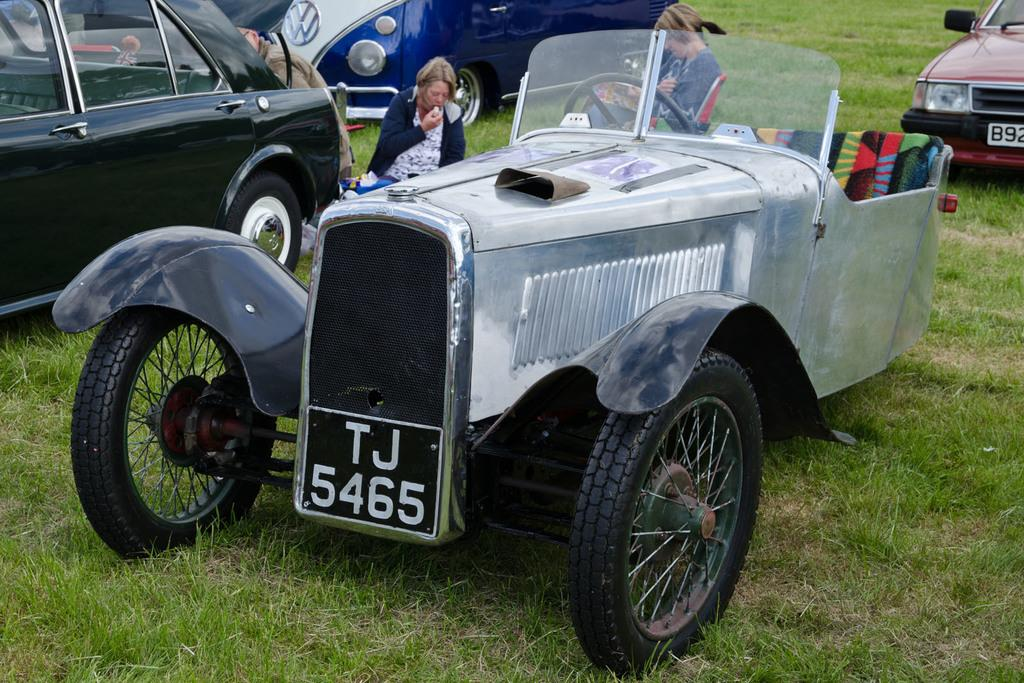How many women are present in the image? There are two women in the image. What are the positions of the women in the image? One woman is sitting on a chair, and the other woman is sitting on the ground. What else can be seen on the ground in the image? Motor vehicles are parked on the ground in the image. What is the weight of the chin of the woman sitting on the ground? There is no information about the weight of the woman's chin in the image, and it is not possible to determine this detail from the image alone. 